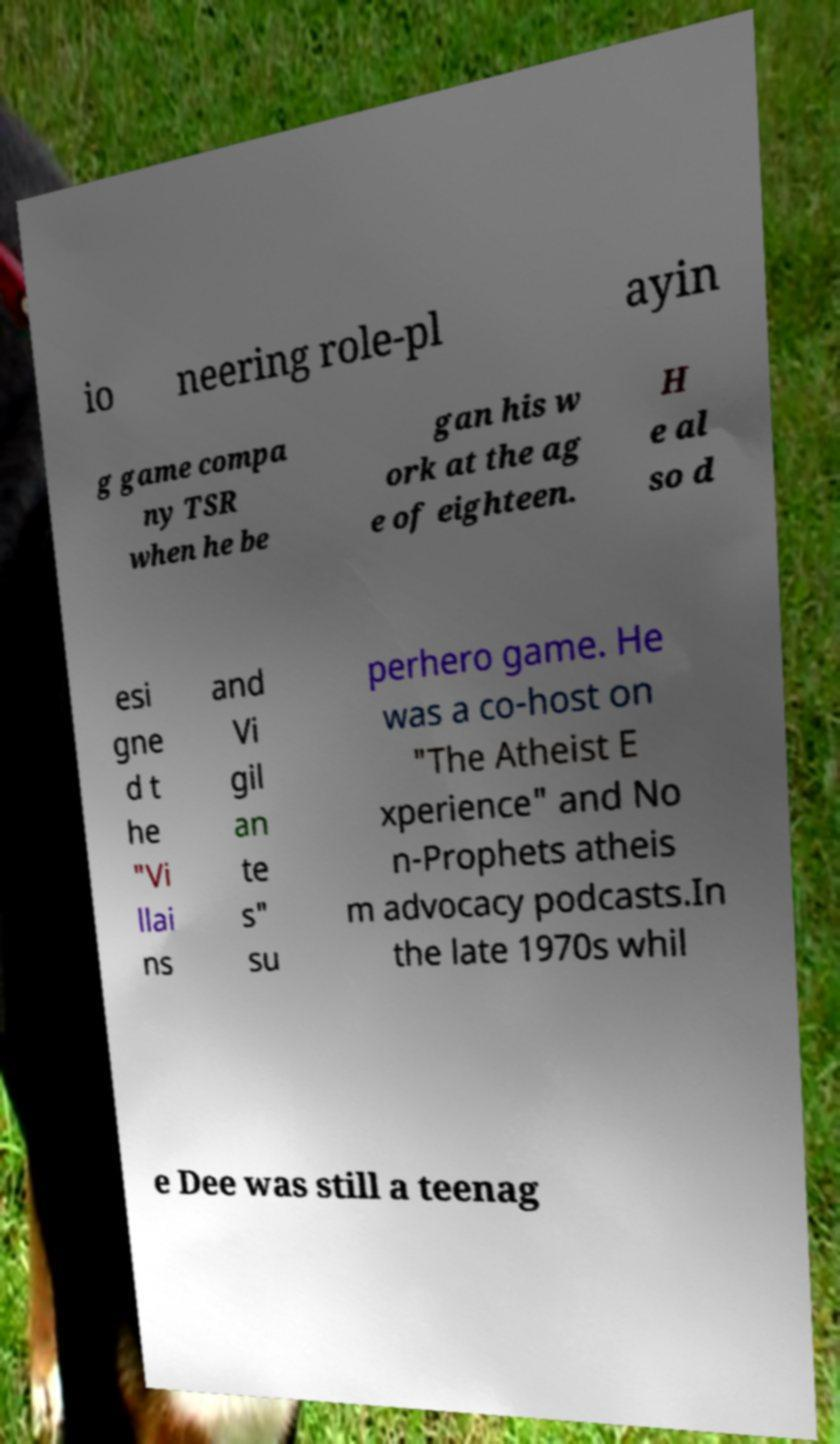Could you extract and type out the text from this image? io neering role-pl ayin g game compa ny TSR when he be gan his w ork at the ag e of eighteen. H e al so d esi gne d t he "Vi llai ns and Vi gil an te s" su perhero game. He was a co-host on "The Atheist E xperience" and No n-Prophets atheis m advocacy podcasts.In the late 1970s whil e Dee was still a teenag 